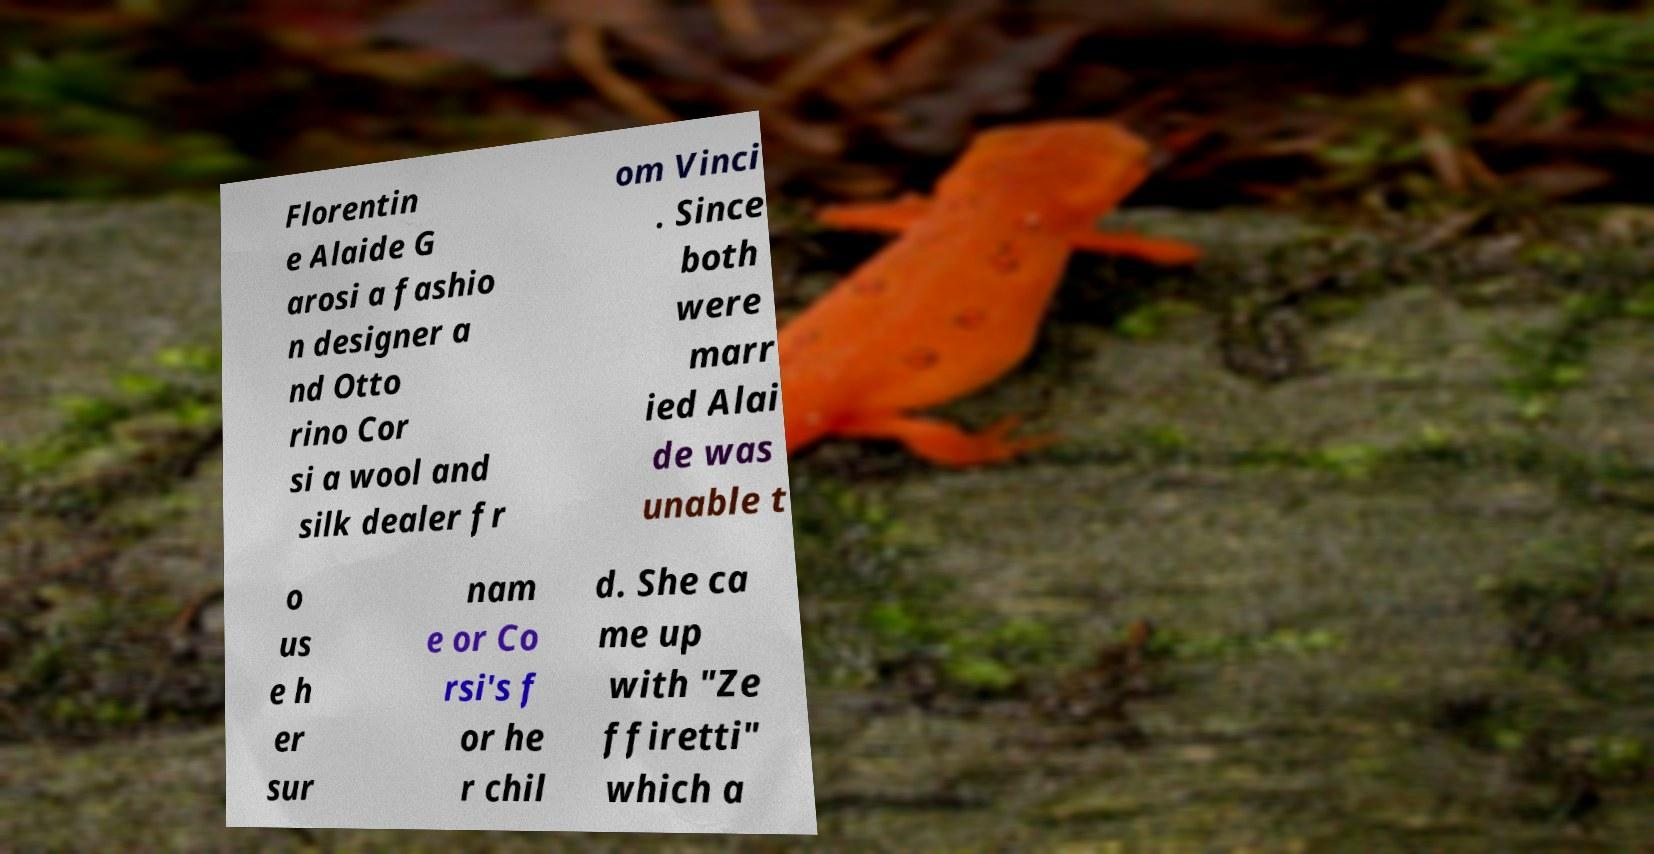What messages or text are displayed in this image? I need them in a readable, typed format. Florentin e Alaide G arosi a fashio n designer a nd Otto rino Cor si a wool and silk dealer fr om Vinci . Since both were marr ied Alai de was unable t o us e h er sur nam e or Co rsi's f or he r chil d. She ca me up with "Ze ffiretti" which a 